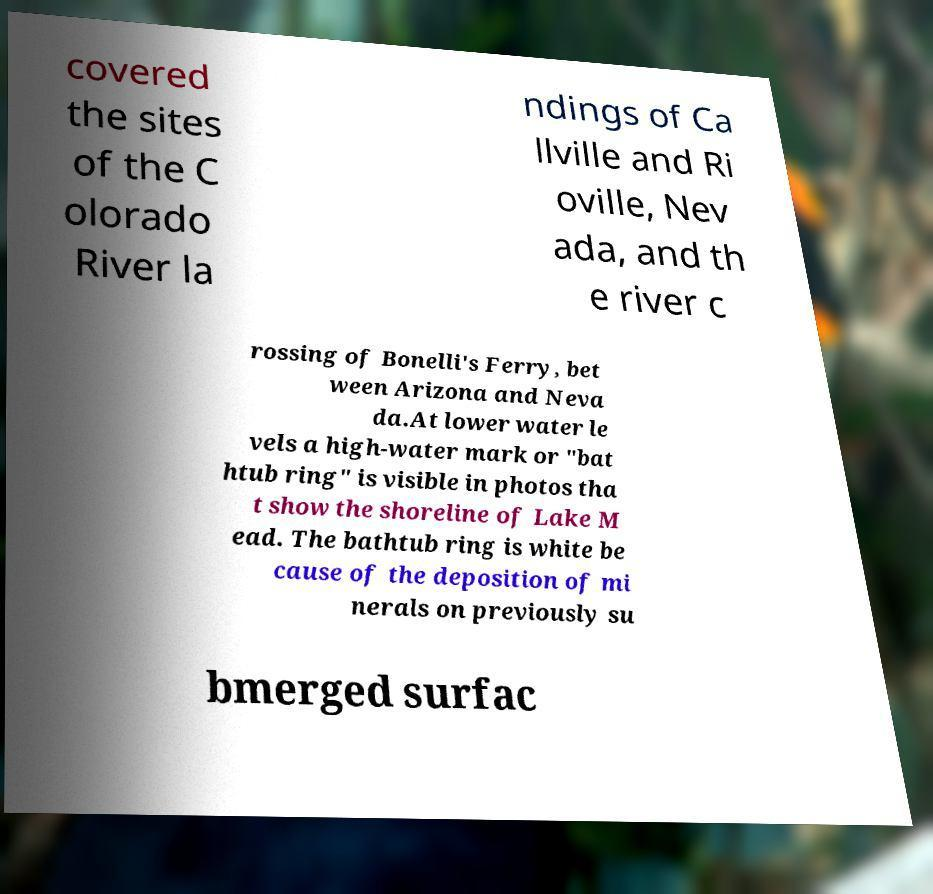For documentation purposes, I need the text within this image transcribed. Could you provide that? covered the sites of the C olorado River la ndings of Ca llville and Ri oville, Nev ada, and th e river c rossing of Bonelli's Ferry, bet ween Arizona and Neva da.At lower water le vels a high-water mark or "bat htub ring" is visible in photos tha t show the shoreline of Lake M ead. The bathtub ring is white be cause of the deposition of mi nerals on previously su bmerged surfac 